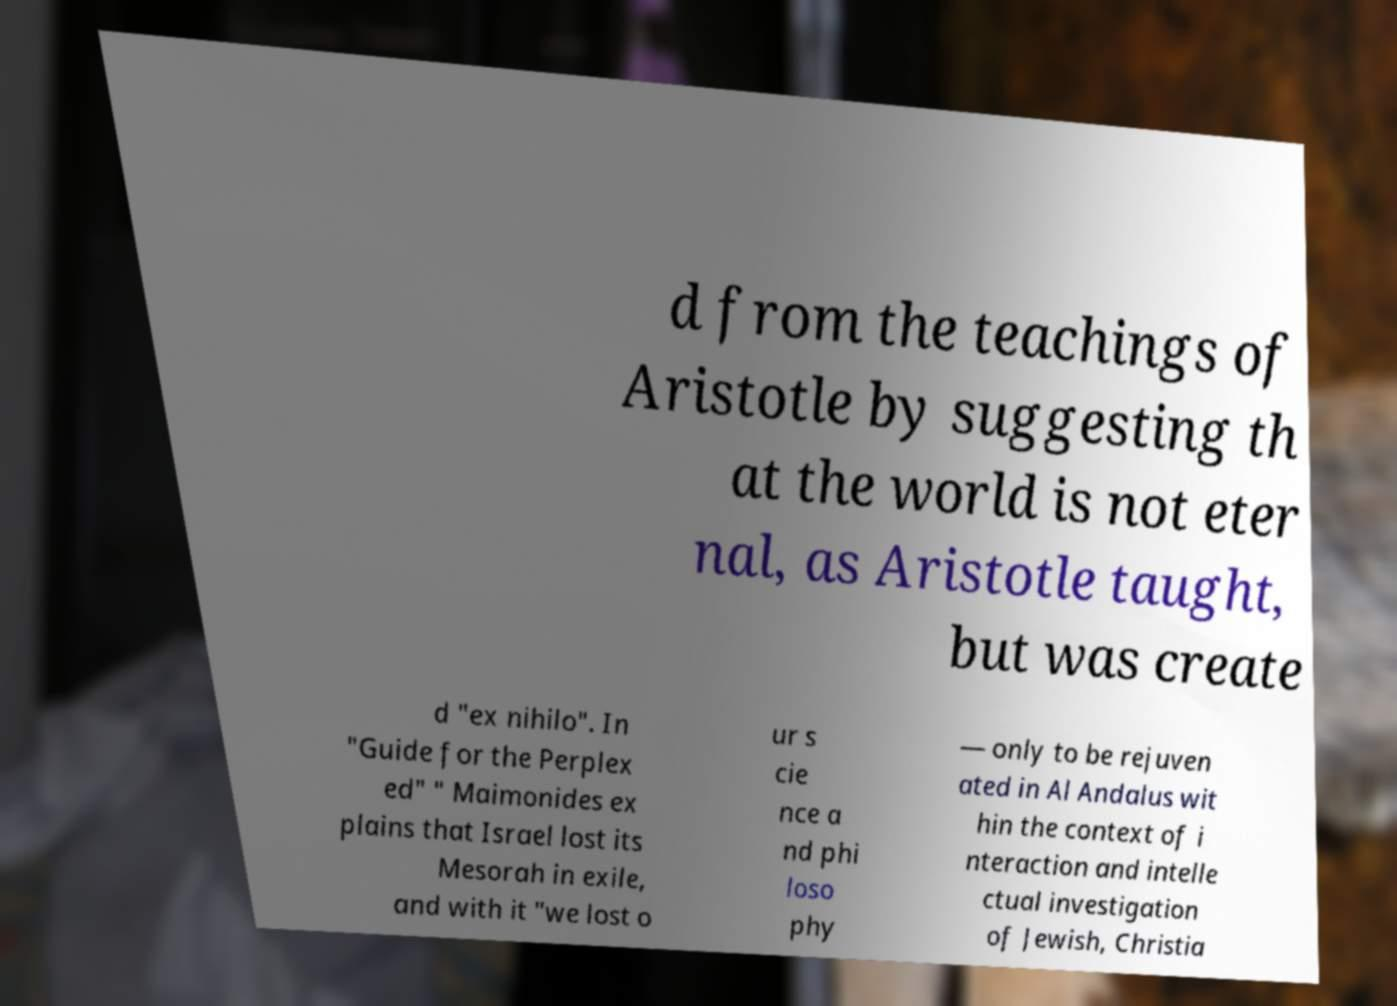Please read and relay the text visible in this image. What does it say? d from the teachings of Aristotle by suggesting th at the world is not eter nal, as Aristotle taught, but was create d "ex nihilo". In "Guide for the Perplex ed" " Maimonides ex plains that Israel lost its Mesorah in exile, and with it "we lost o ur s cie nce a nd phi loso phy — only to be rejuven ated in Al Andalus wit hin the context of i nteraction and intelle ctual investigation of Jewish, Christia 